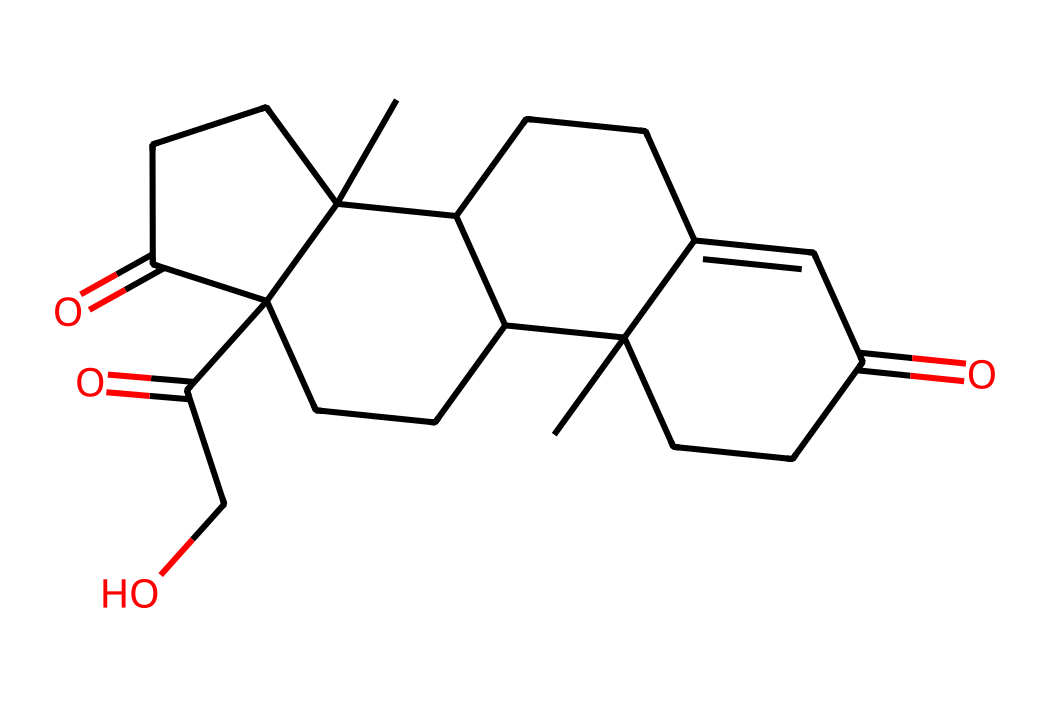What is the molecular formula of cortisol? To find the molecular formula, count the number of each type of atom present in the structure. The SMILES representation shows multiple carbon (C), hydrogen (H), and oxygen (O) atoms, which can be counted to arrive at the formula C21H30O5.
Answer: C21H30O5 How many rings are present in the structure of cortisol? By analyzing the structure, identify the cyclic components. The chemical has four fused rings that can be seen in the structure.
Answer: 4 What functional groups are present in cortisol? Inspecting the structure reveals the presence of ketone (C=O) and hydroxyl (–OH) groups. The oxygen atoms indicate these functional groups.
Answer: ketone and hydroxyl Which atom is responsible for the polarity of cortisol? The presence of oxygen atoms contributes to the polarity. Specifically, the hydroxyl (-OH) groups increase the molecule's polarity by allowing for hydrogen bonding.
Answer: oxygen In competitive sports, what role does cortisol play? Cortisol is known as the stress hormone that helps the body respond to stress. It regulates metabolism and immune response, particularly during intense activities.
Answer: stress response 